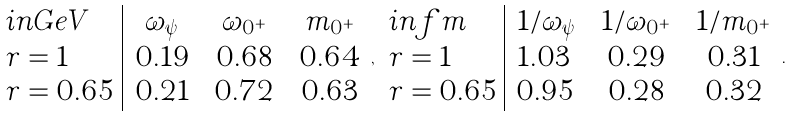<formula> <loc_0><loc_0><loc_500><loc_500>\begin{array} { l | c c c } i n G e V & \, \omega _ { \psi } \, & \, \omega _ { 0 ^ { + } } \, & \, m _ { 0 ^ { + } } \\ r = 1 & \, 0 . 1 9 \, & \, 0 . 6 8 \, & \, 0 . 6 4 \\ r = 0 . 6 5 & \, 0 . 2 1 \, & \, 0 . 7 2 \, & \, 0 . 6 3 \end{array} \, , \, \begin{array} { l | c c c } i n f m & \, 1 / \omega _ { \psi } \, & \, 1 / \omega _ { 0 ^ { + } } \, & \, 1 / m _ { 0 ^ { + } } \\ r = 1 & 1 . 0 3 \, & \, 0 . 2 9 \, & \, 0 . 3 1 \\ r = 0 . 6 5 & 0 . 9 5 \, & \, 0 . 2 8 \, & \, 0 . 3 2 \end{array} \, .</formula> 